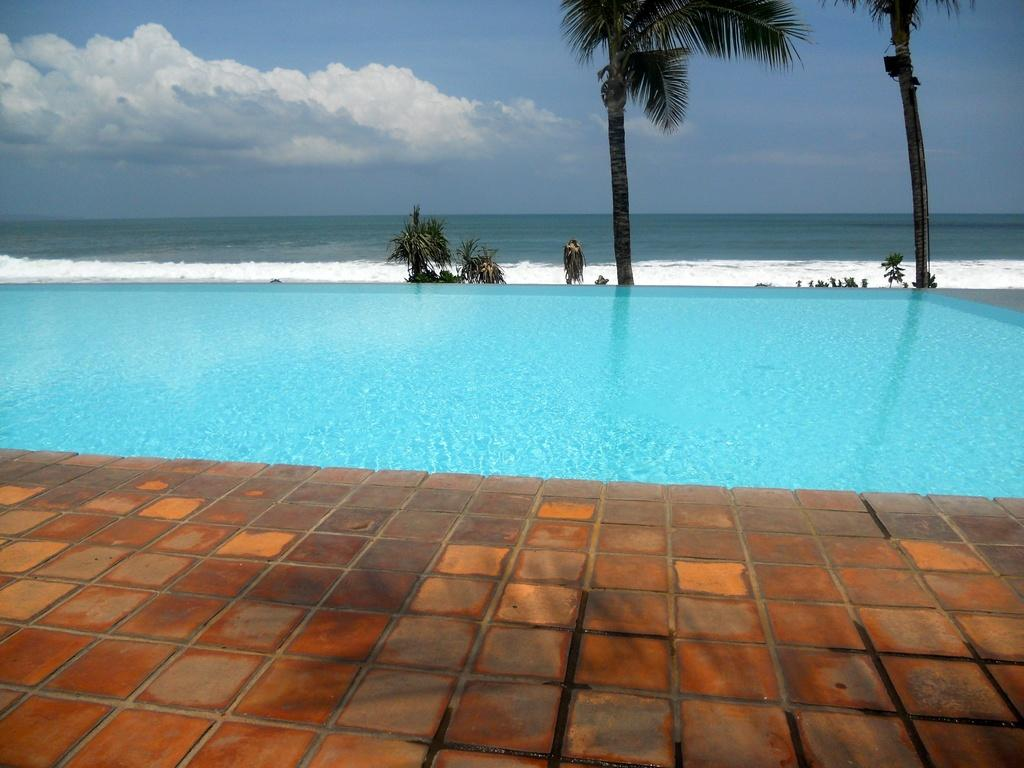What is visible in the image that is not solid? Water is visible in the image and is not solid. What type of vegetation can be seen in the image? Trees are present in the image. What is visible in the background of the image? The sky is visible in the image. What can be seen in the sky in the image? Clouds are present in the sky. What type of ornament is hanging from the tree in the image? There is no ornament hanging from the tree in the image; only trees and clouds are present. What is the income of the person who took the image? The income of the person who took the image is not mentioned or visible in the image, so it cannot be determined. 